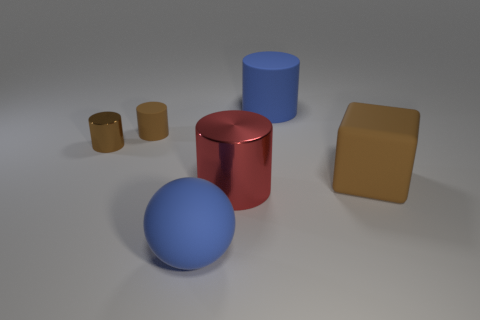Subtract all blue rubber cylinders. How many cylinders are left? 3 Add 4 large matte blocks. How many objects exist? 10 Subtract 1 cylinders. How many cylinders are left? 3 Subtract all blue cylinders. How many cylinders are left? 3 Subtract 0 brown balls. How many objects are left? 6 Subtract all cylinders. How many objects are left? 2 Subtract all cyan spheres. Subtract all cyan cubes. How many spheres are left? 1 Subtract all yellow blocks. How many blue cylinders are left? 1 Subtract all big gray metal cylinders. Subtract all big shiny cylinders. How many objects are left? 5 Add 1 large blue rubber spheres. How many large blue rubber spheres are left? 2 